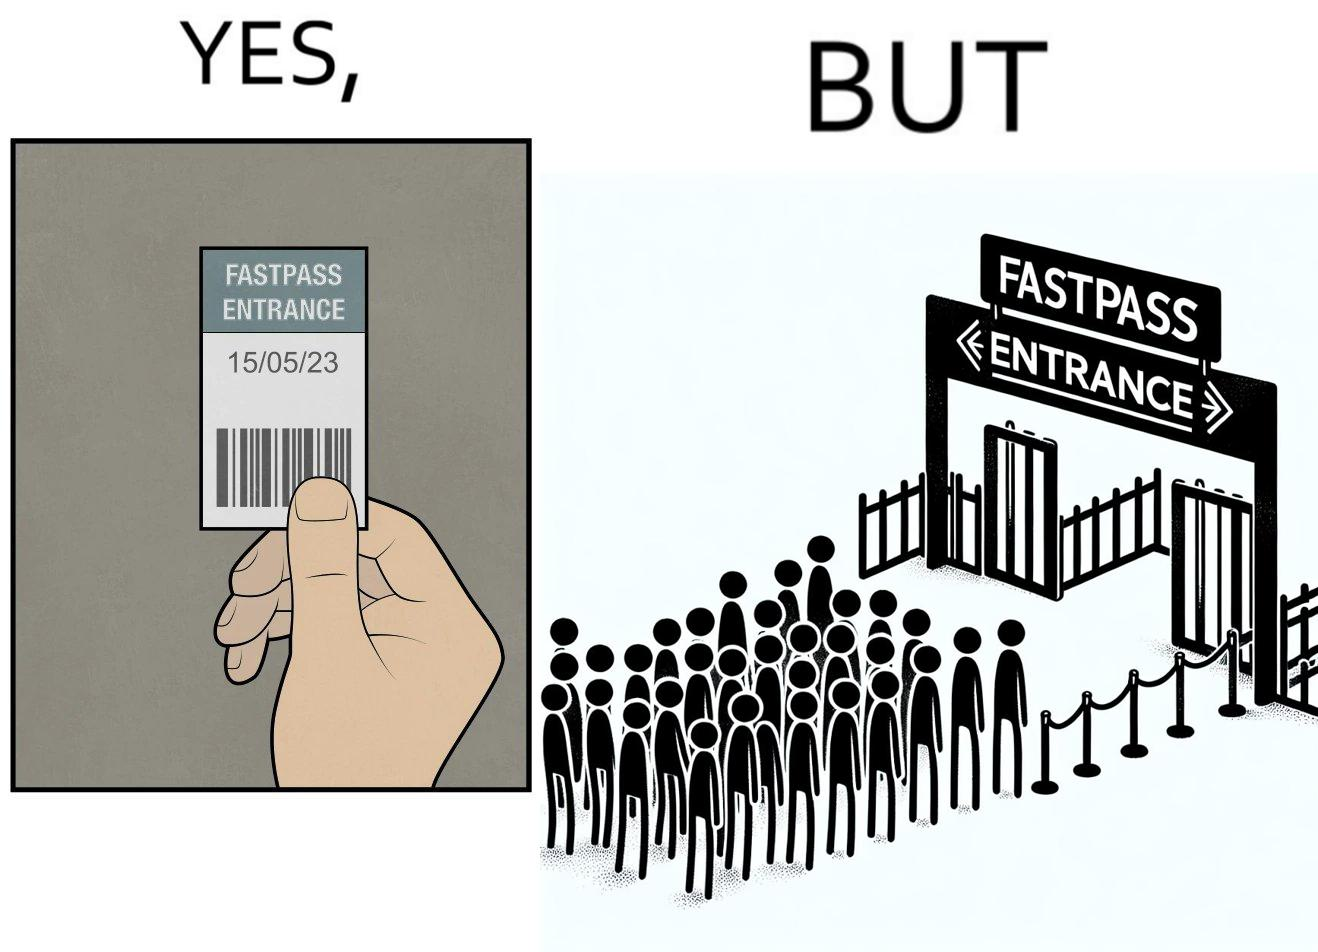Does this image contain satire or humor? Yes, this image is satirical. 